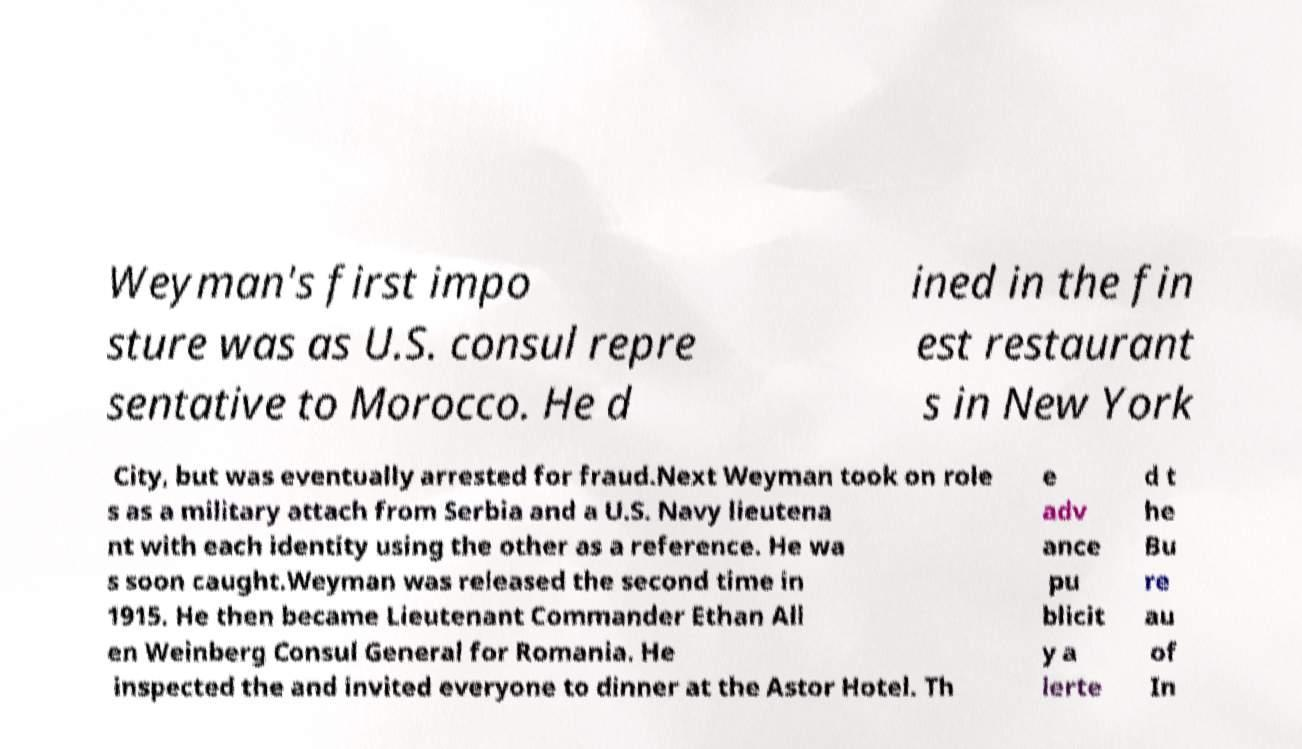What messages or text are displayed in this image? I need them in a readable, typed format. Weyman's first impo sture was as U.S. consul repre sentative to Morocco. He d ined in the fin est restaurant s in New York City, but was eventually arrested for fraud.Next Weyman took on role s as a military attach from Serbia and a U.S. Navy lieutena nt with each identity using the other as a reference. He wa s soon caught.Weyman was released the second time in 1915. He then became Lieutenant Commander Ethan All en Weinberg Consul General for Romania. He inspected the and invited everyone to dinner at the Astor Hotel. Th e adv ance pu blicit y a lerte d t he Bu re au of In 